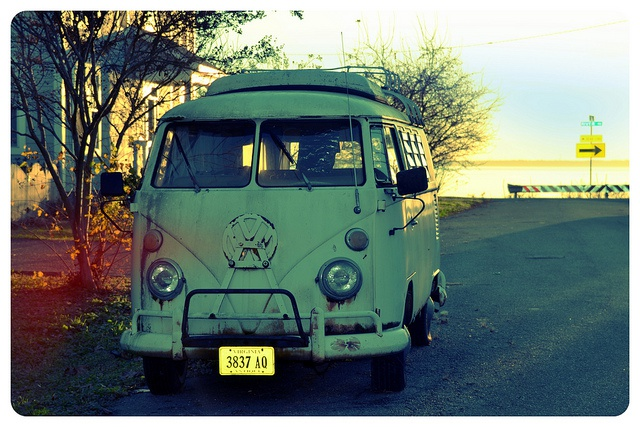Describe the objects in this image and their specific colors. I can see bus in white, teal, and black tones in this image. 